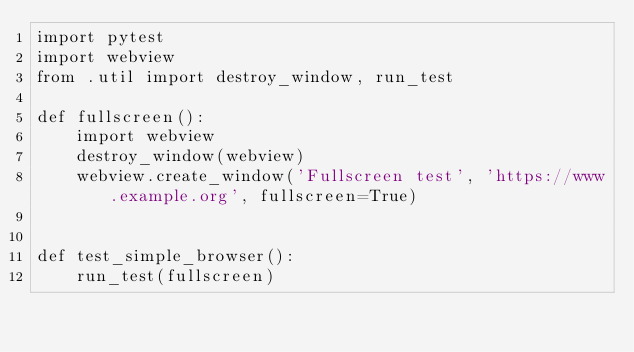Convert code to text. <code><loc_0><loc_0><loc_500><loc_500><_Python_>import pytest
import webview
from .util import destroy_window, run_test

def fullscreen():
    import webview
    destroy_window(webview)
    webview.create_window('Fullscreen test', 'https://www.example.org', fullscreen=True)


def test_simple_browser():
    run_test(fullscreen)
</code> 